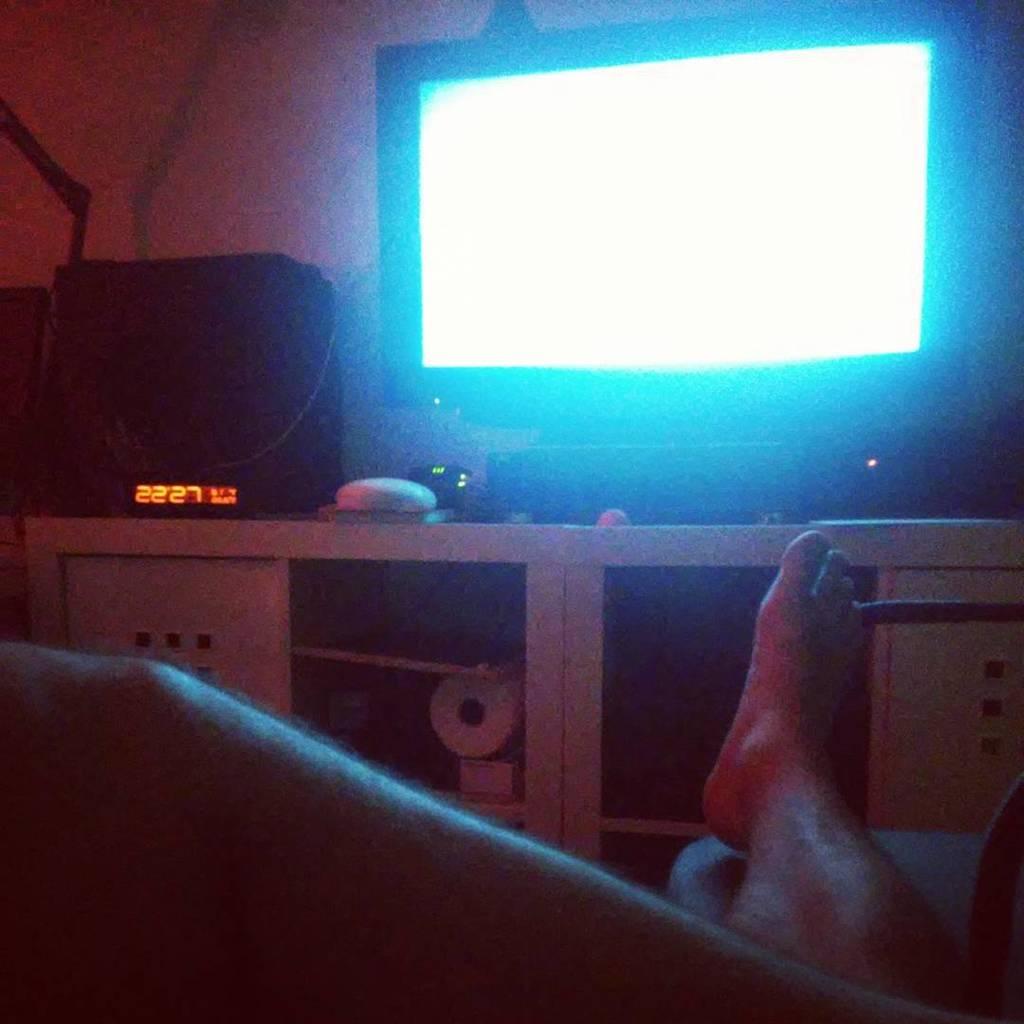What number is seen in orange?
Offer a very short reply. 2227. What are doing?
Your response must be concise. Answering does not require reading text in the image. 